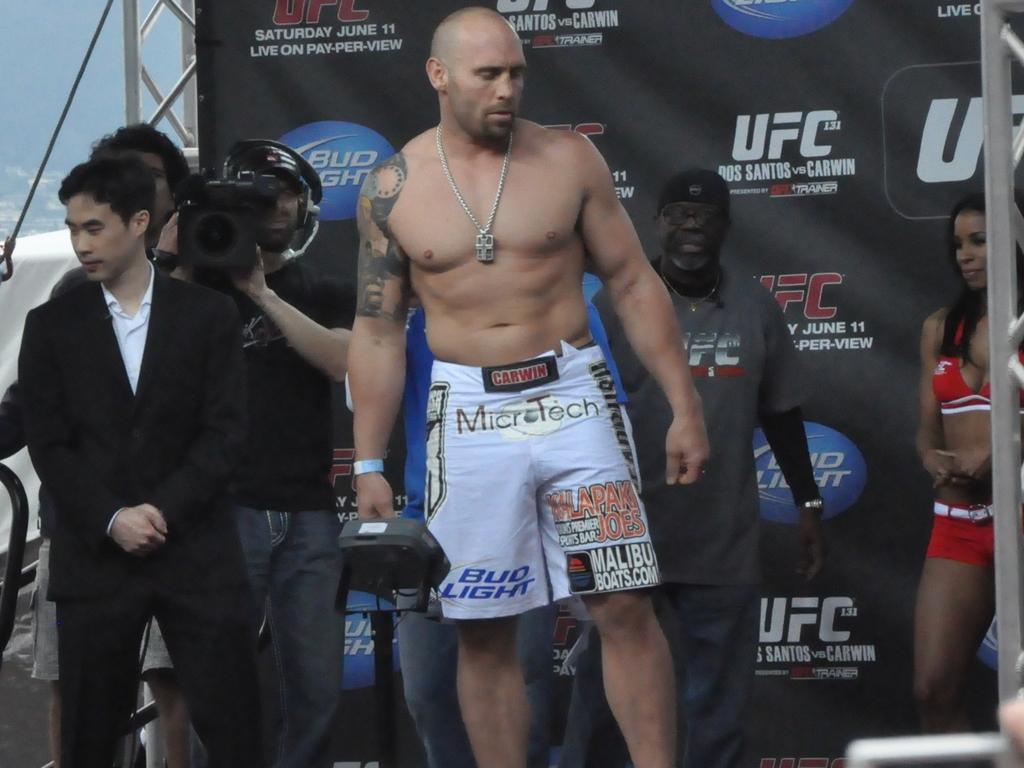Which fighting group is sponsored here?
Your answer should be compact. Ufc. What brand of beer sponsors the fighter?
Make the answer very short. Bud light. 